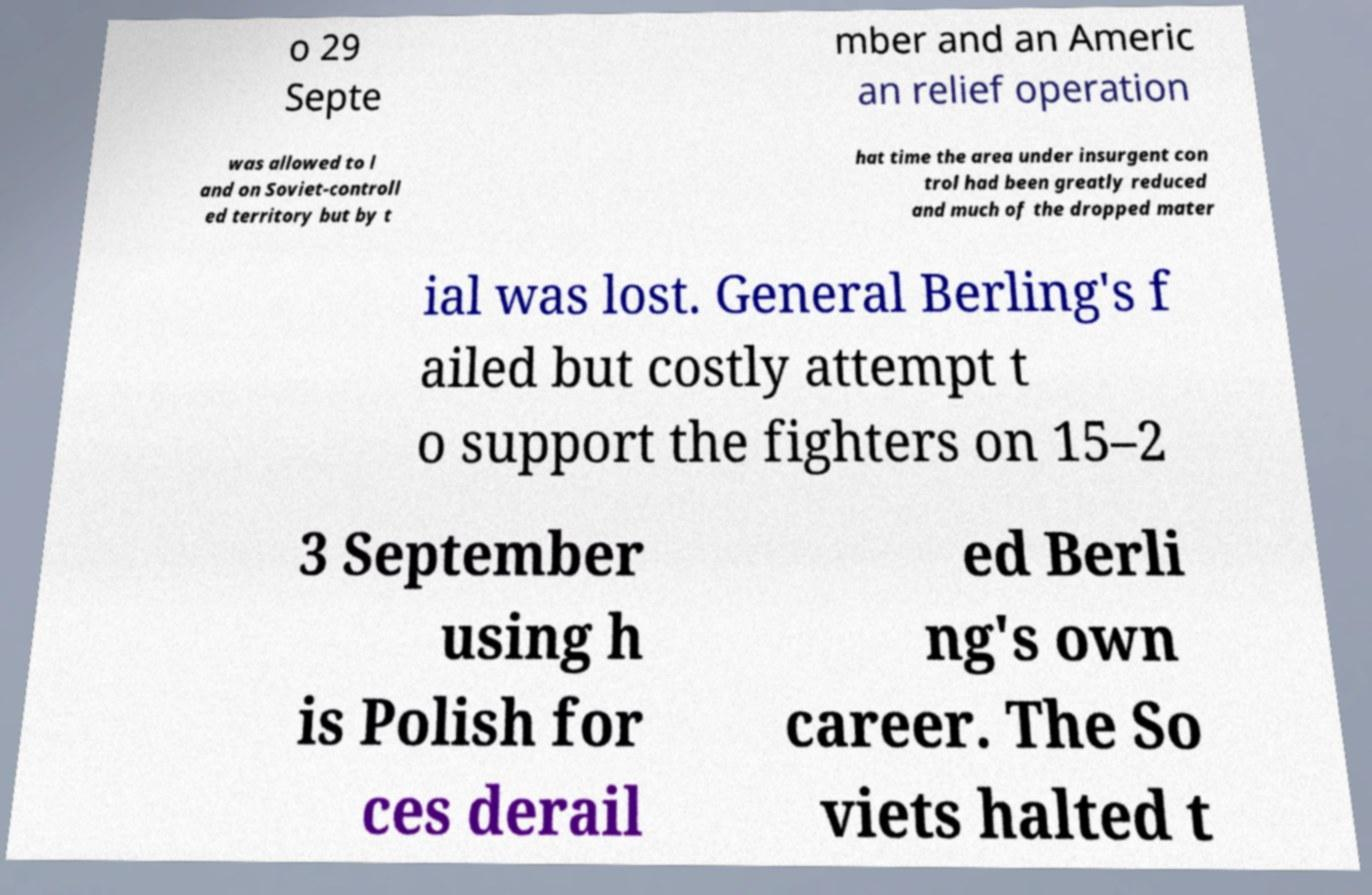Please identify and transcribe the text found in this image. o 29 Septe mber and an Americ an relief operation was allowed to l and on Soviet-controll ed territory but by t hat time the area under insurgent con trol had been greatly reduced and much of the dropped mater ial was lost. General Berling's f ailed but costly attempt t o support the fighters on 15–2 3 September using h is Polish for ces derail ed Berli ng's own career. The So viets halted t 